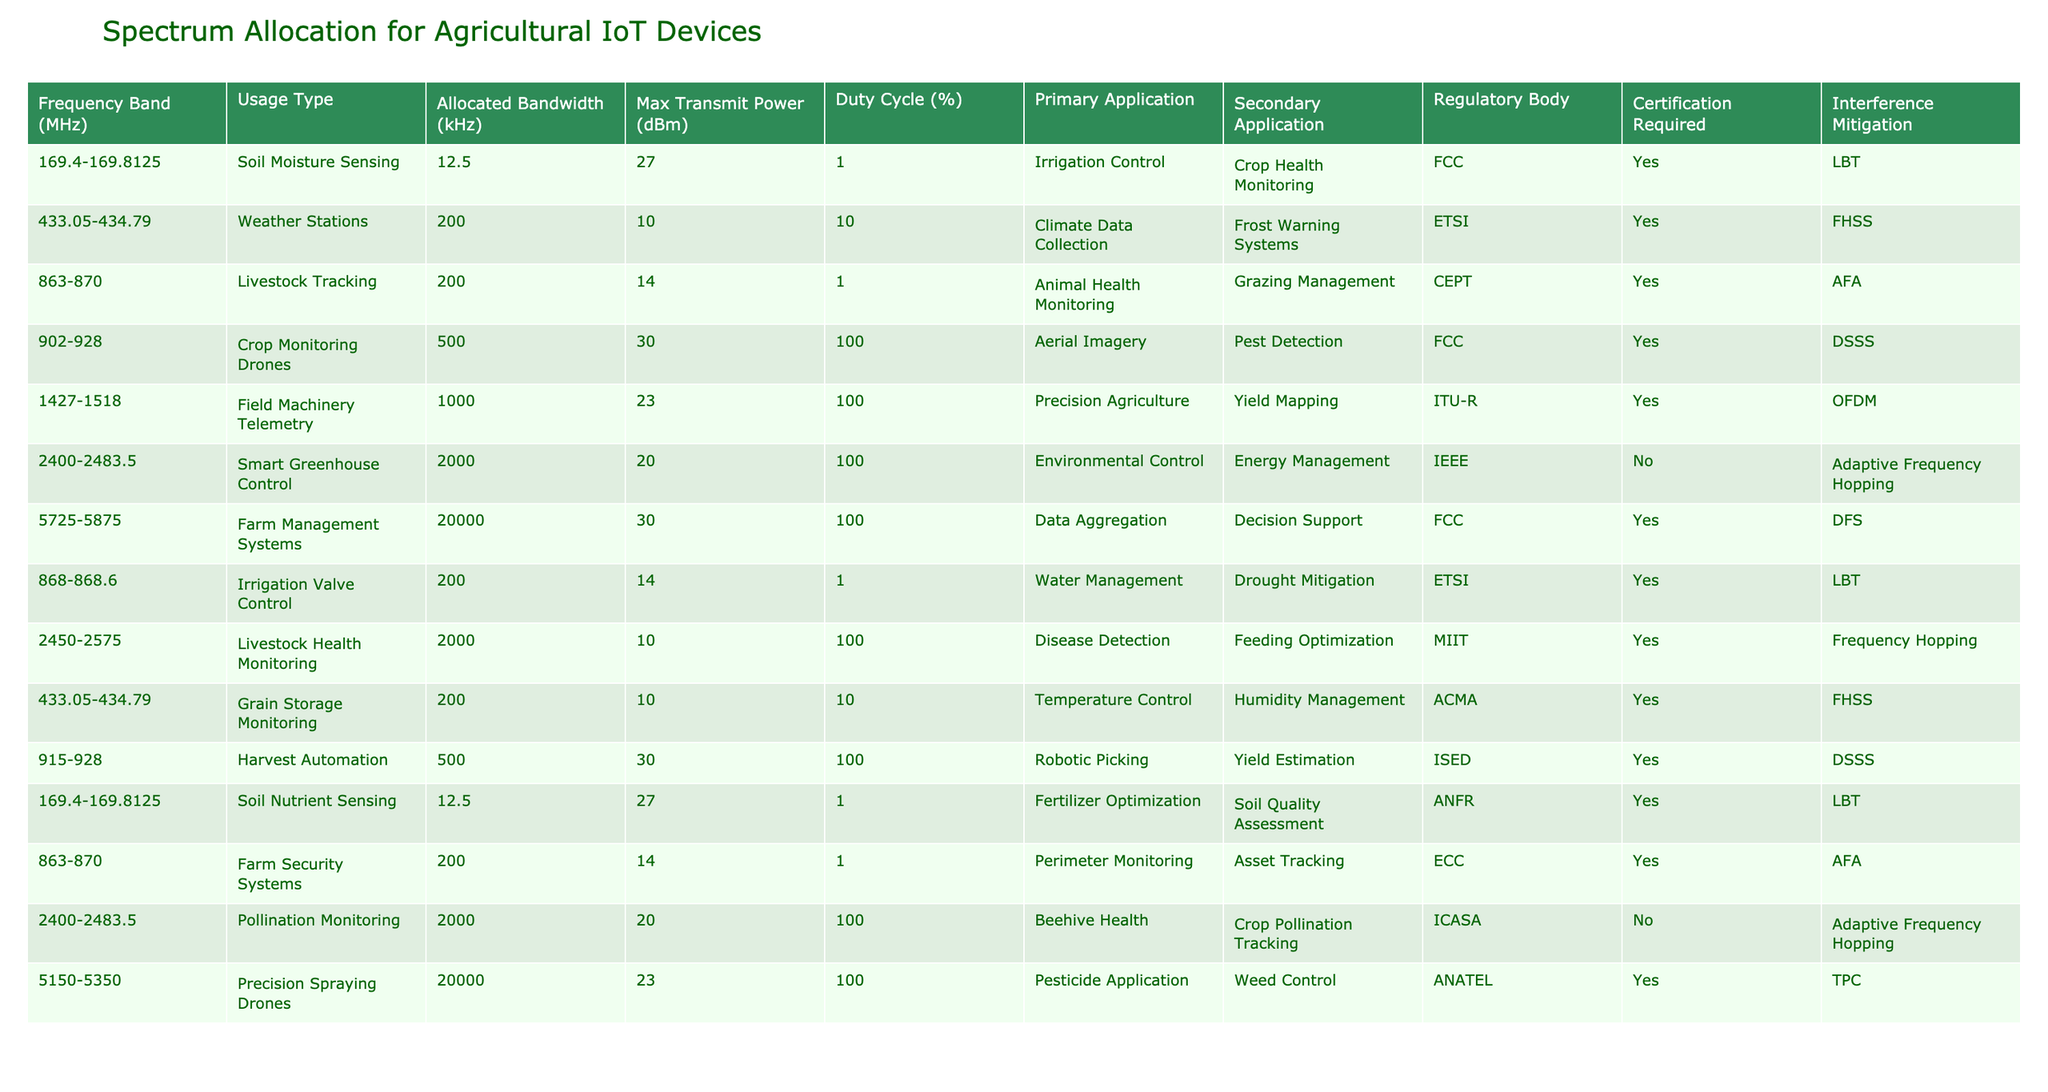What is the allocated bandwidth for Crop Monitoring Drones? According to the table, the allocated bandwidth for Crop Monitoring Drones is listed under the "Allocated Bandwidth (kHz)" column, which is 500 kHz.
Answer: 500 kHz Which frequency band has the highest max transmit power? The max transmit power is found in the "Max Transmit Power (dBm)" column. The highest value listed is 30 dBm, corresponding to the frequency bands 902-928 and 5725-5875.
Answer: 30 dBm How many usage types require certification? By counting the occurrences of "Yes" in the "Certification Required" column, we find 10 out of the 12 entries require certification.
Answer: 10 Is the frequency band 2400-2483.5 used for any applications that do not require certification? We check the "Certification Required" column for the frequency band 2400-2483.5 and see that the Pollination Monitoring application is marked as "No", indicating it does not require certification.
Answer: Yes What is the total allocated bandwidth for Soil Moisture Sensing applications? The allocated bandwidth for Soil Moisture Sensing is recorded as 12.5 kHz in two entries. Adding these gives us 12.5 + 12.5 = 25 kHz.
Answer: 25 kHz What is the difference in max transmit power between Farm Management Systems and Smart Greenhouse Control? Looking at the "Max Transmit Power (dBm)" values, Farm Management Systems has 30 dBm, and Smart Greenhouse Control has 20 dBm. The difference is 30 - 20 = 10 dBm.
Answer: 10 dBm Which primary application has the lowest duty cycle? By reviewing the "Duty Cycle (%)" column, Soil Moisture Sensing and Livestock Tracking are both listed at 1%, which is the lowest duty cycle present.
Answer: 1% How many frequency bands are allocated for livestock-related applications? By examining the table, we see that there are three entries under primary applications related to livestock: Livestock Tracking, Livestock Health Monitoring, and Animal Health Monitoring. Therefore, there are 3 frequency bands for livestock.
Answer: 3 What is the average max transmit power for applications that have a duty cycle of 100%? Considering only the applications with a duty cycle of 100%, we have the following max transmit powers: 30, 23, 20, and 30 dBm. The average is (30 + 23 + 20 + 30) / 4 = 25.75 dBm.
Answer: 25.75 dBm Which frequency band is associated with Field Machinery Telemetry? By checking the "Primary Application" column, we see that Field Machinery Telemetry is associated with the frequency band 1427-1518 MHz.
Answer: 1427-1518 MHz 